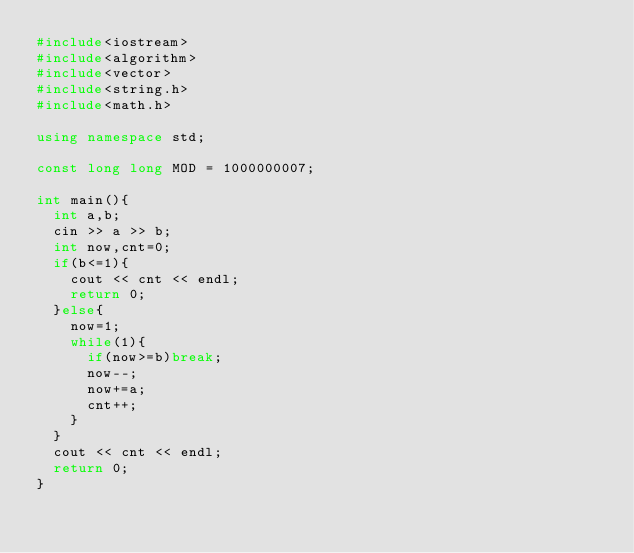Convert code to text. <code><loc_0><loc_0><loc_500><loc_500><_C++_>#include<iostream>
#include<algorithm>
#include<vector>
#include<string.h>
#include<math.h>

using namespace std;

const long long MOD = 1000000007;

int main(){
	int a,b;
	cin >> a >> b;
	int now,cnt=0;
	if(b<=1){
		cout << cnt << endl;
		return 0;
	}else{
		now=1;
		while(1){
			if(now>=b)break;
			now--;
			now+=a;
			cnt++;
		}
	}
	cout << cnt << endl;
	return 0;
}
</code> 